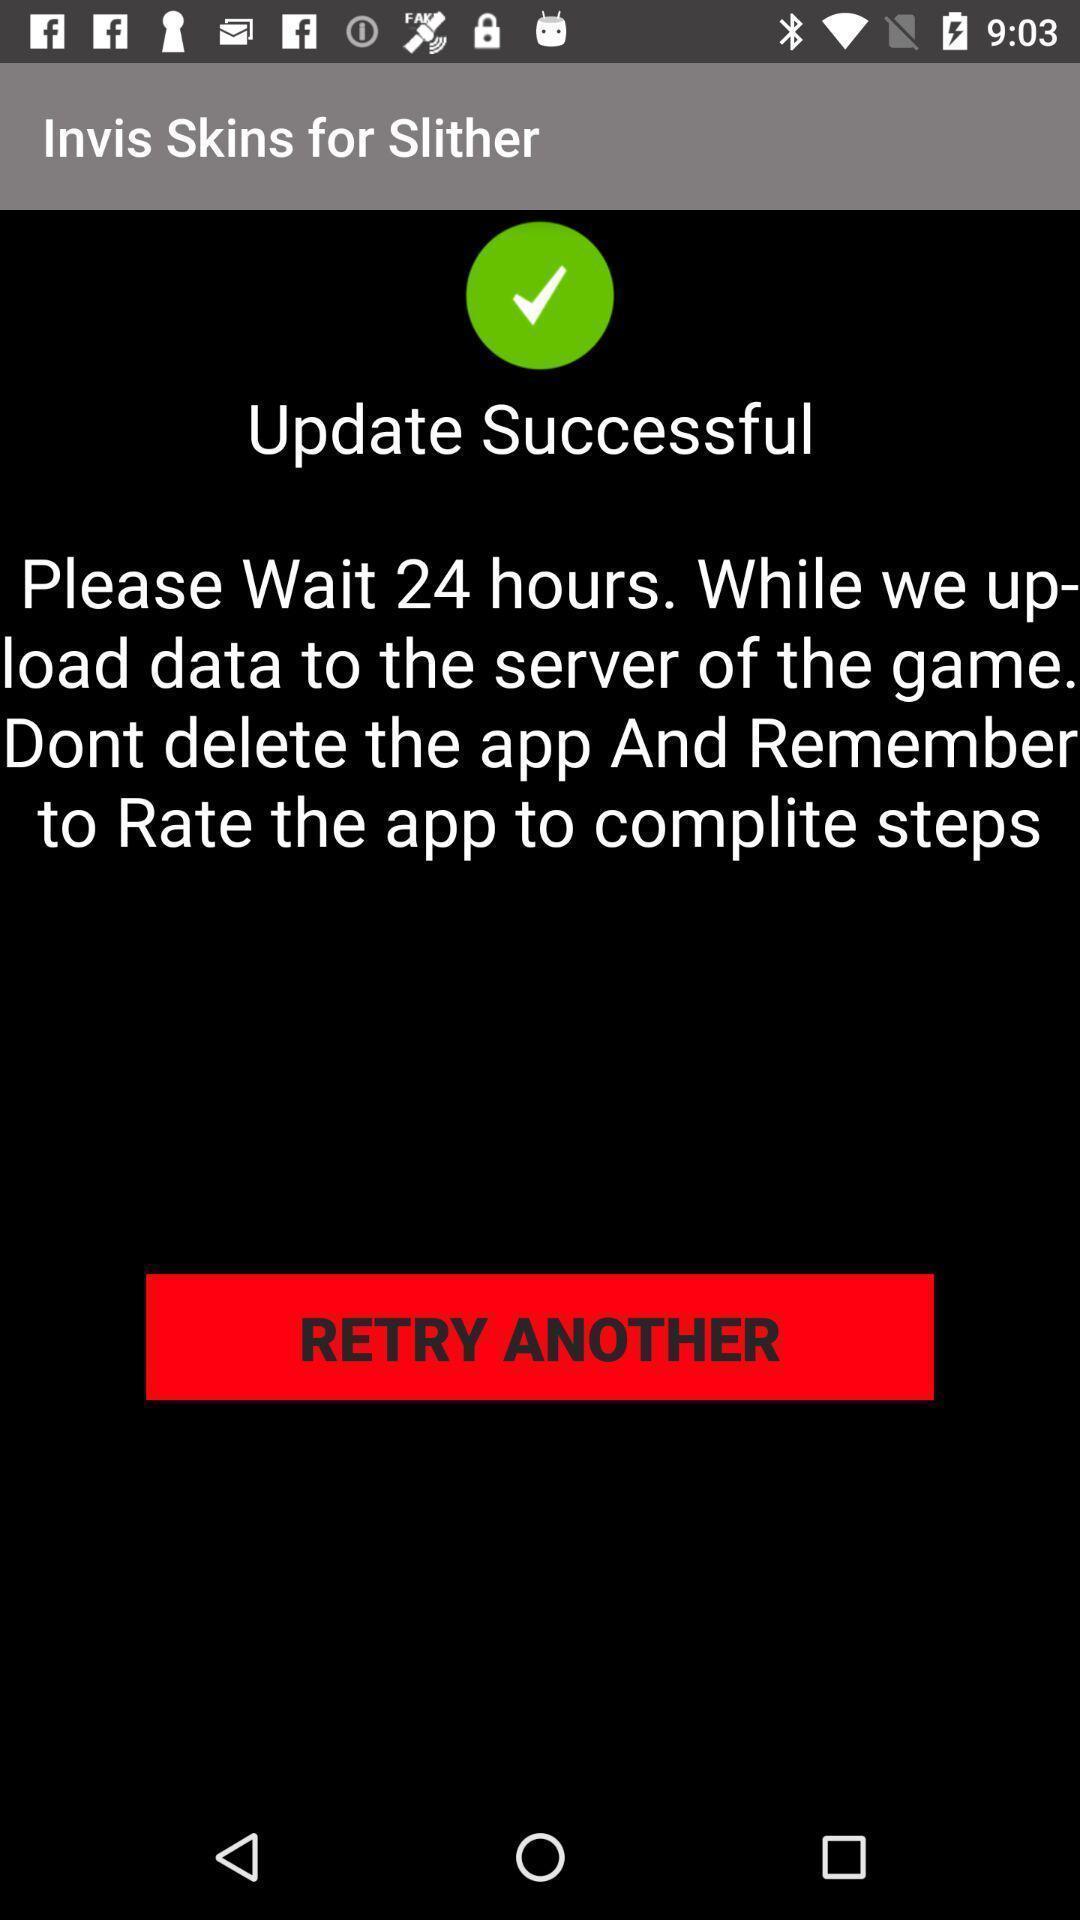Provide a textual representation of this image. Update status displaying in application. 